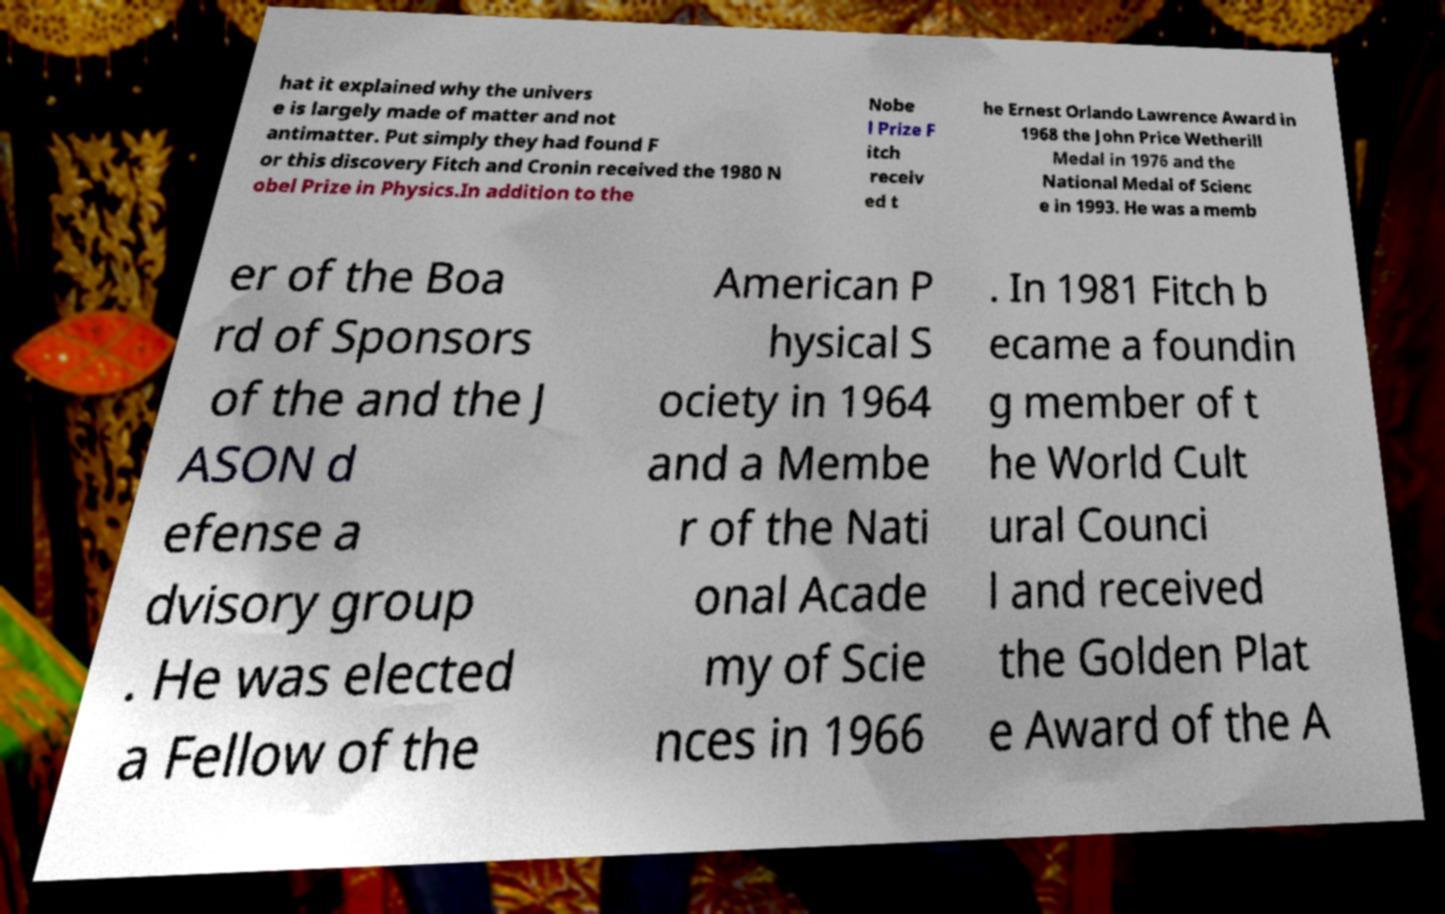I need the written content from this picture converted into text. Can you do that? hat it explained why the univers e is largely made of matter and not antimatter. Put simply they had found F or this discovery Fitch and Cronin received the 1980 N obel Prize in Physics.In addition to the Nobe l Prize F itch receiv ed t he Ernest Orlando Lawrence Award in 1968 the John Price Wetherill Medal in 1976 and the National Medal of Scienc e in 1993. He was a memb er of the Boa rd of Sponsors of the and the J ASON d efense a dvisory group . He was elected a Fellow of the American P hysical S ociety in 1964 and a Membe r of the Nati onal Acade my of Scie nces in 1966 . In 1981 Fitch b ecame a foundin g member of t he World Cult ural Counci l and received the Golden Plat e Award of the A 